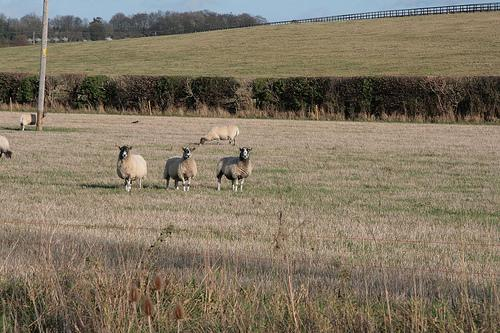In a few words, describe the activity taking place in the image. Herd of sheep grazing in a field. What are the main elements seen within the image? Sheep grazing, a large grassy field, a tall wooden pole, a fence on a hilltop, and thick green bushes. What are the most noticeable features of the sheep in the image? White and tan wool, some eating grass, and a variety of sizes and positions. What is the color of the sky and any other natural elements in the image? The sky is blue, the grass is green and the bushes and trees are also green. Mention the primary subjects in the image and their surroundings. Sheep grazing in the grass, surrounded by a fence, a pole, thick bushes, and an empty field behind the bushes. In one sentence, describe the overall composition and setting of the image. A tranquil scene with a herd of sheep grazing amongst a large grassy field, surrounded by thick green bushes and a fence on a hilltop. Provide a brief description of the scene in the image. A herd of sheep is grazing in a large grassy field, with a row of thick green bushes and a fence in the background. Describe the key elements of the image using adjectives. Lush green grass, peaceful grazing sheep, wooden pole, imposing fence, and dense row of bushes. Provide a brief comment on the environment depicted in the image. A serene and picturesque countryside setting perfect for a shepherd and their flock. Mention any objects in the image that are made by humans.  A tall wooden pole, a fence on a hilltop, and two thin parallel wires. 